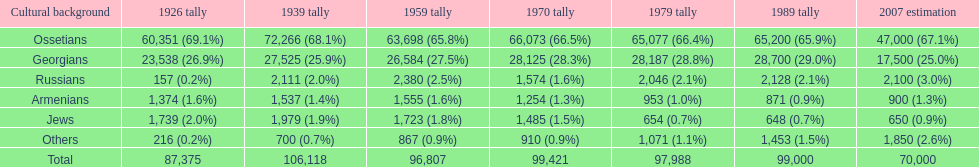What was the population of russians in south ossetia in 1970? 1,574. Could you parse the entire table as a dict? {'header': ['Cultural background', '1926 tally', '1939 tally', '1959 tally', '1970 tally', '1979 tally', '1989 tally', '2007 estimation'], 'rows': [['Ossetians', '60,351 (69.1%)', '72,266 (68.1%)', '63,698 (65.8%)', '66,073 (66.5%)', '65,077 (66.4%)', '65,200 (65.9%)', '47,000 (67.1%)'], ['Georgians', '23,538 (26.9%)', '27,525 (25.9%)', '26,584 (27.5%)', '28,125 (28.3%)', '28,187 (28.8%)', '28,700 (29.0%)', '17,500 (25.0%)'], ['Russians', '157 (0.2%)', '2,111 (2.0%)', '2,380 (2.5%)', '1,574 (1.6%)', '2,046 (2.1%)', '2,128 (2.1%)', '2,100 (3.0%)'], ['Armenians', '1,374 (1.6%)', '1,537 (1.4%)', '1,555 (1.6%)', '1,254 (1.3%)', '953 (1.0%)', '871 (0.9%)', '900 (1.3%)'], ['Jews', '1,739 (2.0%)', '1,979 (1.9%)', '1,723 (1.8%)', '1,485 (1.5%)', '654 (0.7%)', '648 (0.7%)', '650 (0.9%)'], ['Others', '216 (0.2%)', '700 (0.7%)', '867 (0.9%)', '910 (0.9%)', '1,071 (1.1%)', '1,453 (1.5%)', '1,850 (2.6%)'], ['Total', '87,375', '106,118', '96,807', '99,421', '97,988', '99,000', '70,000']]} 